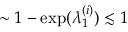<formula> <loc_0><loc_0><loc_500><loc_500>\sim 1 - \exp ( \lambda _ { 1 } ^ { ( i ) } ) \lesssim 1</formula> 